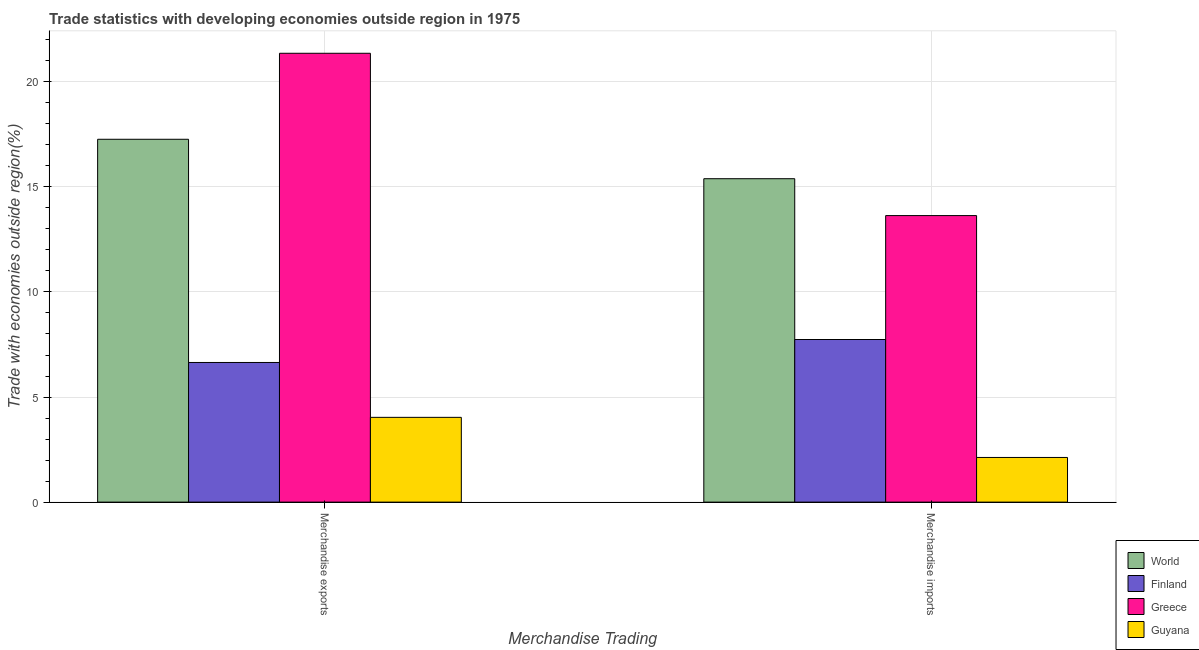How many groups of bars are there?
Give a very brief answer. 2. What is the label of the 1st group of bars from the left?
Provide a short and direct response. Merchandise exports. What is the merchandise exports in World?
Provide a short and direct response. 17.27. Across all countries, what is the maximum merchandise imports?
Ensure brevity in your answer.  15.39. Across all countries, what is the minimum merchandise exports?
Your answer should be compact. 4.03. In which country was the merchandise imports maximum?
Ensure brevity in your answer.  World. In which country was the merchandise imports minimum?
Give a very brief answer. Guyana. What is the total merchandise exports in the graph?
Provide a succinct answer. 49.3. What is the difference between the merchandise exports in World and that in Finland?
Your answer should be very brief. 10.62. What is the difference between the merchandise exports in Guyana and the merchandise imports in World?
Offer a terse response. -11.35. What is the average merchandise imports per country?
Give a very brief answer. 9.72. What is the difference between the merchandise exports and merchandise imports in World?
Offer a terse response. 1.88. What is the ratio of the merchandise exports in World to that in Finland?
Ensure brevity in your answer.  2.6. Is the merchandise exports in World less than that in Greece?
Your answer should be compact. Yes. What does the 2nd bar from the left in Merchandise exports represents?
Keep it short and to the point. Finland. What does the 1st bar from the right in Merchandise imports represents?
Keep it short and to the point. Guyana. How many bars are there?
Your answer should be compact. 8. Are all the bars in the graph horizontal?
Ensure brevity in your answer.  No. What is the difference between two consecutive major ticks on the Y-axis?
Offer a very short reply. 5. Does the graph contain any zero values?
Provide a short and direct response. No. Where does the legend appear in the graph?
Ensure brevity in your answer.  Bottom right. What is the title of the graph?
Ensure brevity in your answer.  Trade statistics with developing economies outside region in 1975. What is the label or title of the X-axis?
Offer a very short reply. Merchandise Trading. What is the label or title of the Y-axis?
Give a very brief answer. Trade with economies outside region(%). What is the Trade with economies outside region(%) in World in Merchandise exports?
Provide a succinct answer. 17.27. What is the Trade with economies outside region(%) in Finland in Merchandise exports?
Keep it short and to the point. 6.64. What is the Trade with economies outside region(%) in Greece in Merchandise exports?
Offer a very short reply. 21.36. What is the Trade with economies outside region(%) in Guyana in Merchandise exports?
Provide a short and direct response. 4.03. What is the Trade with economies outside region(%) in World in Merchandise imports?
Offer a very short reply. 15.39. What is the Trade with economies outside region(%) in Finland in Merchandise imports?
Give a very brief answer. 7.74. What is the Trade with economies outside region(%) in Greece in Merchandise imports?
Offer a very short reply. 13.63. What is the Trade with economies outside region(%) of Guyana in Merchandise imports?
Offer a terse response. 2.12. Across all Merchandise Trading, what is the maximum Trade with economies outside region(%) of World?
Provide a short and direct response. 17.27. Across all Merchandise Trading, what is the maximum Trade with economies outside region(%) in Finland?
Your response must be concise. 7.74. Across all Merchandise Trading, what is the maximum Trade with economies outside region(%) in Greece?
Provide a succinct answer. 21.36. Across all Merchandise Trading, what is the maximum Trade with economies outside region(%) in Guyana?
Offer a very short reply. 4.03. Across all Merchandise Trading, what is the minimum Trade with economies outside region(%) of World?
Offer a terse response. 15.39. Across all Merchandise Trading, what is the minimum Trade with economies outside region(%) in Finland?
Keep it short and to the point. 6.64. Across all Merchandise Trading, what is the minimum Trade with economies outside region(%) in Greece?
Offer a very short reply. 13.63. Across all Merchandise Trading, what is the minimum Trade with economies outside region(%) of Guyana?
Provide a succinct answer. 2.12. What is the total Trade with economies outside region(%) of World in the graph?
Provide a short and direct response. 32.65. What is the total Trade with economies outside region(%) in Finland in the graph?
Make the answer very short. 14.38. What is the total Trade with economies outside region(%) in Greece in the graph?
Offer a very short reply. 34.99. What is the total Trade with economies outside region(%) in Guyana in the graph?
Provide a short and direct response. 6.16. What is the difference between the Trade with economies outside region(%) in World in Merchandise exports and that in Merchandise imports?
Your response must be concise. 1.88. What is the difference between the Trade with economies outside region(%) of Finland in Merchandise exports and that in Merchandise imports?
Make the answer very short. -1.09. What is the difference between the Trade with economies outside region(%) in Greece in Merchandise exports and that in Merchandise imports?
Offer a very short reply. 7.72. What is the difference between the Trade with economies outside region(%) of Guyana in Merchandise exports and that in Merchandise imports?
Your response must be concise. 1.91. What is the difference between the Trade with economies outside region(%) of World in Merchandise exports and the Trade with economies outside region(%) of Finland in Merchandise imports?
Provide a short and direct response. 9.53. What is the difference between the Trade with economies outside region(%) of World in Merchandise exports and the Trade with economies outside region(%) of Greece in Merchandise imports?
Keep it short and to the point. 3.63. What is the difference between the Trade with economies outside region(%) in World in Merchandise exports and the Trade with economies outside region(%) in Guyana in Merchandise imports?
Make the answer very short. 15.14. What is the difference between the Trade with economies outside region(%) of Finland in Merchandise exports and the Trade with economies outside region(%) of Greece in Merchandise imports?
Make the answer very short. -6.99. What is the difference between the Trade with economies outside region(%) in Finland in Merchandise exports and the Trade with economies outside region(%) in Guyana in Merchandise imports?
Your response must be concise. 4.52. What is the difference between the Trade with economies outside region(%) in Greece in Merchandise exports and the Trade with economies outside region(%) in Guyana in Merchandise imports?
Your response must be concise. 19.23. What is the average Trade with economies outside region(%) of World per Merchandise Trading?
Offer a terse response. 16.33. What is the average Trade with economies outside region(%) in Finland per Merchandise Trading?
Provide a succinct answer. 7.19. What is the average Trade with economies outside region(%) of Greece per Merchandise Trading?
Offer a terse response. 17.5. What is the average Trade with economies outside region(%) of Guyana per Merchandise Trading?
Ensure brevity in your answer.  3.08. What is the difference between the Trade with economies outside region(%) in World and Trade with economies outside region(%) in Finland in Merchandise exports?
Make the answer very short. 10.62. What is the difference between the Trade with economies outside region(%) of World and Trade with economies outside region(%) of Greece in Merchandise exports?
Provide a short and direct response. -4.09. What is the difference between the Trade with economies outside region(%) in World and Trade with economies outside region(%) in Guyana in Merchandise exports?
Offer a very short reply. 13.23. What is the difference between the Trade with economies outside region(%) of Finland and Trade with economies outside region(%) of Greece in Merchandise exports?
Make the answer very short. -14.71. What is the difference between the Trade with economies outside region(%) of Finland and Trade with economies outside region(%) of Guyana in Merchandise exports?
Offer a terse response. 2.61. What is the difference between the Trade with economies outside region(%) in Greece and Trade with economies outside region(%) in Guyana in Merchandise exports?
Make the answer very short. 17.32. What is the difference between the Trade with economies outside region(%) of World and Trade with economies outside region(%) of Finland in Merchandise imports?
Your answer should be compact. 7.65. What is the difference between the Trade with economies outside region(%) of World and Trade with economies outside region(%) of Greece in Merchandise imports?
Keep it short and to the point. 1.75. What is the difference between the Trade with economies outside region(%) in World and Trade with economies outside region(%) in Guyana in Merchandise imports?
Your response must be concise. 13.26. What is the difference between the Trade with economies outside region(%) of Finland and Trade with economies outside region(%) of Greece in Merchandise imports?
Make the answer very short. -5.9. What is the difference between the Trade with economies outside region(%) in Finland and Trade with economies outside region(%) in Guyana in Merchandise imports?
Make the answer very short. 5.61. What is the difference between the Trade with economies outside region(%) of Greece and Trade with economies outside region(%) of Guyana in Merchandise imports?
Provide a succinct answer. 11.51. What is the ratio of the Trade with economies outside region(%) in World in Merchandise exports to that in Merchandise imports?
Offer a very short reply. 1.12. What is the ratio of the Trade with economies outside region(%) in Finland in Merchandise exports to that in Merchandise imports?
Offer a terse response. 0.86. What is the ratio of the Trade with economies outside region(%) of Greece in Merchandise exports to that in Merchandise imports?
Your answer should be very brief. 1.57. What is the ratio of the Trade with economies outside region(%) in Guyana in Merchandise exports to that in Merchandise imports?
Your answer should be compact. 1.9. What is the difference between the highest and the second highest Trade with economies outside region(%) in World?
Give a very brief answer. 1.88. What is the difference between the highest and the second highest Trade with economies outside region(%) of Finland?
Make the answer very short. 1.09. What is the difference between the highest and the second highest Trade with economies outside region(%) of Greece?
Keep it short and to the point. 7.72. What is the difference between the highest and the second highest Trade with economies outside region(%) of Guyana?
Make the answer very short. 1.91. What is the difference between the highest and the lowest Trade with economies outside region(%) in World?
Your answer should be compact. 1.88. What is the difference between the highest and the lowest Trade with economies outside region(%) in Finland?
Your answer should be compact. 1.09. What is the difference between the highest and the lowest Trade with economies outside region(%) in Greece?
Your answer should be compact. 7.72. What is the difference between the highest and the lowest Trade with economies outside region(%) of Guyana?
Give a very brief answer. 1.91. 